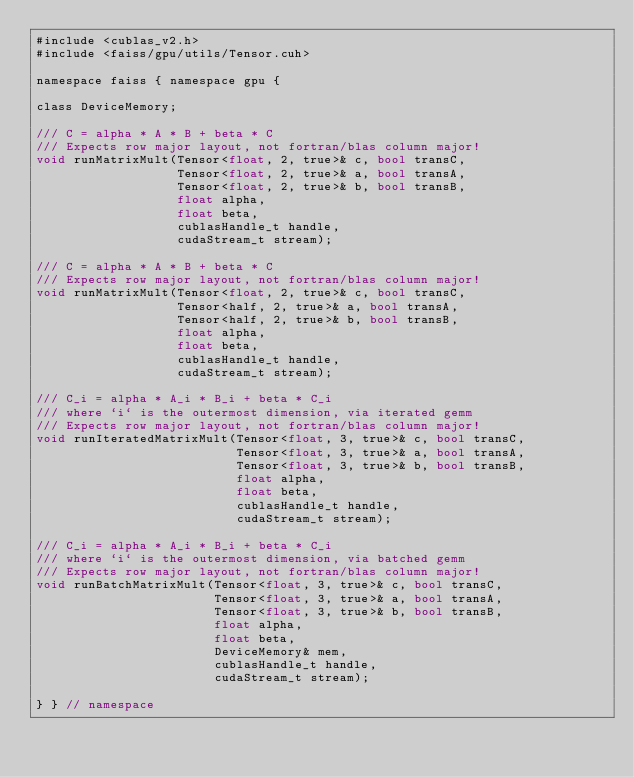<code> <loc_0><loc_0><loc_500><loc_500><_Cuda_>#include <cublas_v2.h>
#include <faiss/gpu/utils/Tensor.cuh>

namespace faiss { namespace gpu {

class DeviceMemory;

/// C = alpha * A * B + beta * C
/// Expects row major layout, not fortran/blas column major!
void runMatrixMult(Tensor<float, 2, true>& c, bool transC,
                   Tensor<float, 2, true>& a, bool transA,
                   Tensor<float, 2, true>& b, bool transB,
                   float alpha,
                   float beta,
                   cublasHandle_t handle,
                   cudaStream_t stream);

/// C = alpha * A * B + beta * C
/// Expects row major layout, not fortran/blas column major!
void runMatrixMult(Tensor<float, 2, true>& c, bool transC,
                   Tensor<half, 2, true>& a, bool transA,
                   Tensor<half, 2, true>& b, bool transB,
                   float alpha,
                   float beta,
                   cublasHandle_t handle,
                   cudaStream_t stream);

/// C_i = alpha * A_i * B_i + beta * C_i
/// where `i` is the outermost dimension, via iterated gemm
/// Expects row major layout, not fortran/blas column major!
void runIteratedMatrixMult(Tensor<float, 3, true>& c, bool transC,
                           Tensor<float, 3, true>& a, bool transA,
                           Tensor<float, 3, true>& b, bool transB,
                           float alpha,
                           float beta,
                           cublasHandle_t handle,
                           cudaStream_t stream);

/// C_i = alpha * A_i * B_i + beta * C_i
/// where `i` is the outermost dimension, via batched gemm
/// Expects row major layout, not fortran/blas column major!
void runBatchMatrixMult(Tensor<float, 3, true>& c, bool transC,
                        Tensor<float, 3, true>& a, bool transA,
                        Tensor<float, 3, true>& b, bool transB,
                        float alpha,
                        float beta,
                        DeviceMemory& mem,
                        cublasHandle_t handle,
                        cudaStream_t stream);

} } // namespace
</code> 